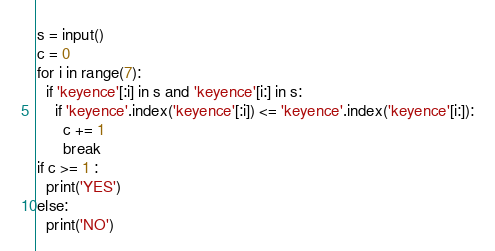Convert code to text. <code><loc_0><loc_0><loc_500><loc_500><_Python_>s = input()
c = 0
for i in range(7):
  if 'keyence'[:i] in s and 'keyence'[i:] in s:
    if 'keyence'.index('keyence'[:i]) <= 'keyence'.index('keyence'[i:]):
      c += 1
      break
if c >= 1 :
  print('YES')
else:
  print('NO')</code> 